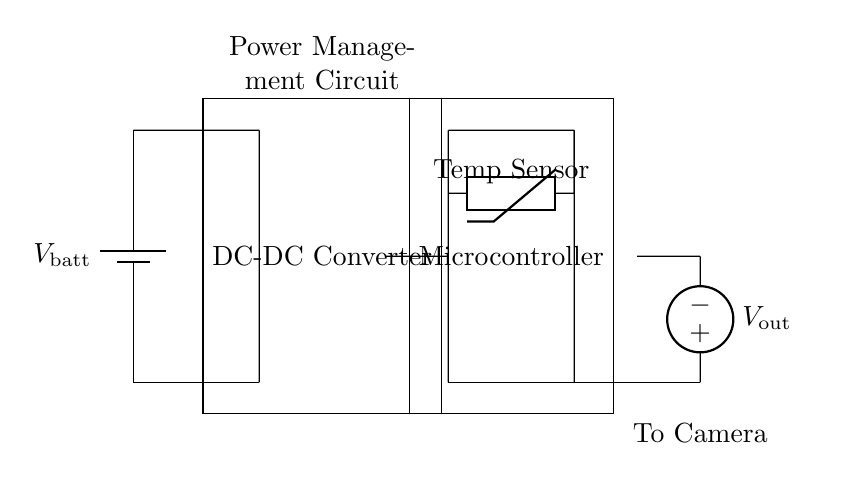What is the main purpose of this circuit? The main purpose is to extend camera battery life in cold conditions by managing power efficiently. The circuit includes a DC-DC converter for voltage regulation and a temperature sensor to monitor cold conditions.
Answer: extend camera battery life What component provides the output voltage? The output voltage is provided by the American voltage source, which is connected to the camera power output. It is responsible for delivering the required voltage to power the camera.
Answer: American voltage source How many main components are in the circuit? There are four main components: a battery, a DC-DC converter, a temperature sensor, and a microcontroller. Each component plays a role in managing the power supply and monitoring conditions.
Answer: four What role does the temperature sensor play in this circuit? The temperature sensor detects ambient temperature to help the microcontroller make decisions about power management. It ensures optimal operation of the camera in cold conditions, affecting how the DC-DC converter functions.
Answer: power management decisions What is the input voltage source of the circuit? The input voltage source is the battery labeled as V_batt, which supplies the initial power for the entire circuit. It is essential for the operation of other components like the DC-DC converter.
Answer: V_batt Which component is responsible for voltage conversion? The DC-DC converter is responsible for converting the battery voltage to the appropriate level required by the camera. It dynamically adjusts the output based on the battery voltage and load conditions.
Answer: DC-DC Converter 